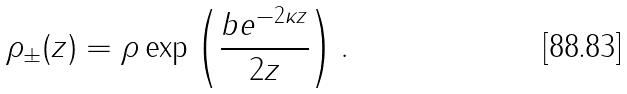<formula> <loc_0><loc_0><loc_500><loc_500>\rho _ { \pm } ( z ) = \rho \exp \left ( \frac { b e ^ { - 2 \kappa z } } { 2 z } \right ) .</formula> 